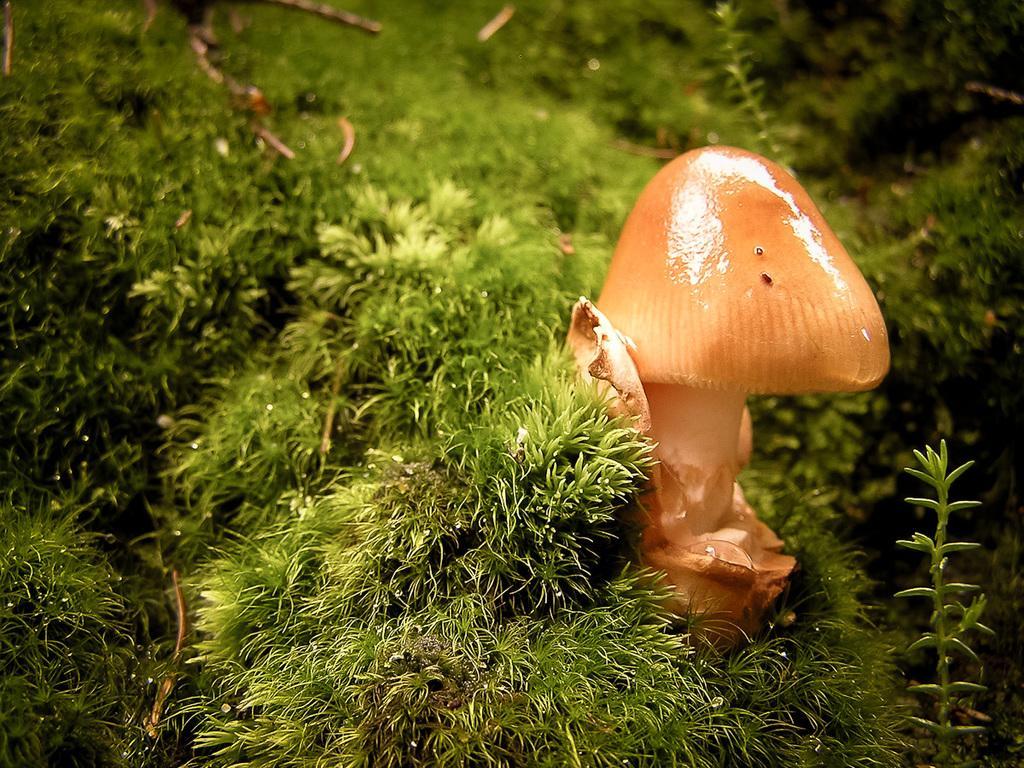Can you describe this image briefly? On the right side of this image there is a mushroom. Around this I can see the grass. In the bottom right there is a plant. 